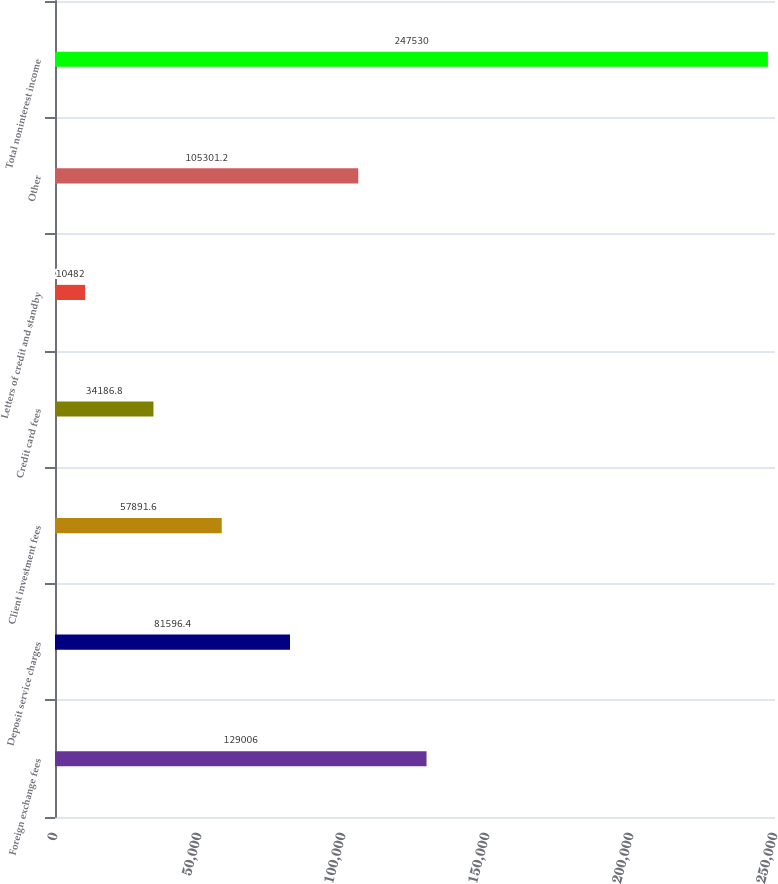<chart> <loc_0><loc_0><loc_500><loc_500><bar_chart><fcel>Foreign exchange fees<fcel>Deposit service charges<fcel>Client investment fees<fcel>Credit card fees<fcel>Letters of credit and standby<fcel>Other<fcel>Total noninterest income<nl><fcel>129006<fcel>81596.4<fcel>57891.6<fcel>34186.8<fcel>10482<fcel>105301<fcel>247530<nl></chart> 